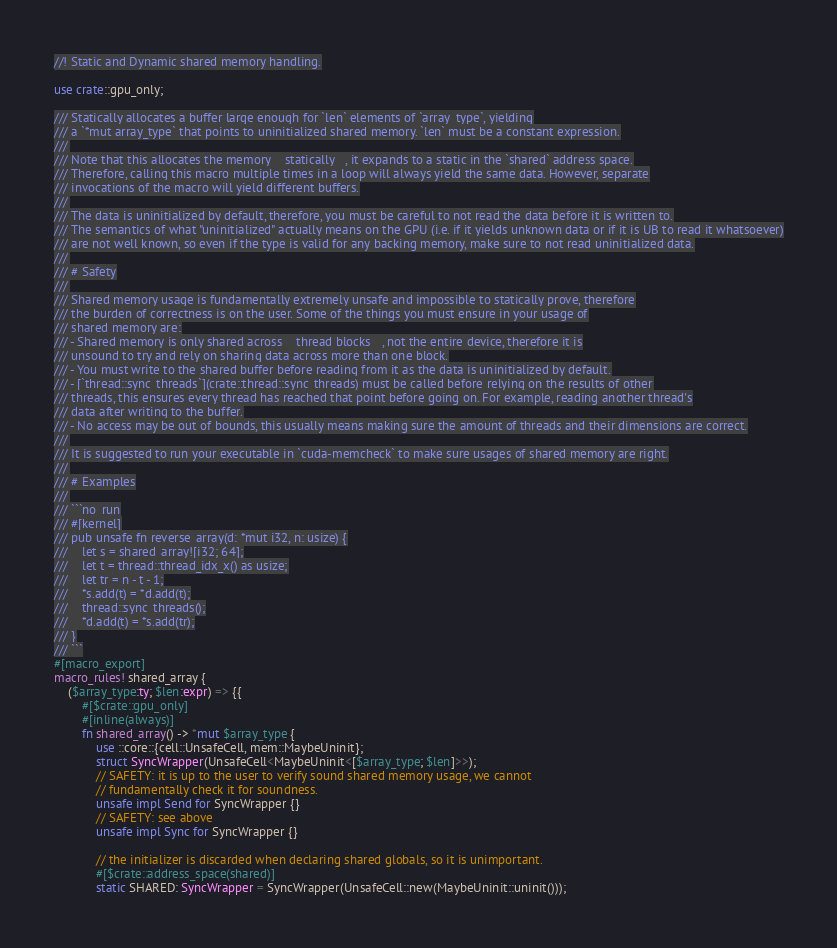<code> <loc_0><loc_0><loc_500><loc_500><_Rust_>//! Static and Dynamic shared memory handling.

use crate::gpu_only;

/// Statically allocates a buffer large enough for `len` elements of `array_type`, yielding
/// a `*mut array_type` that points to uninitialized shared memory. `len` must be a constant expression.
///
/// Note that this allocates the memory __statically__, it expands to a static in the `shared` address space.
/// Therefore, calling this macro multiple times in a loop will always yield the same data. However, separate
/// invocations of the macro will yield different buffers.
///
/// The data is uninitialized by default, therefore, you must be careful to not read the data before it is written to.
/// The semantics of what "uninitialized" actually means on the GPU (i.e. if it yields unknown data or if it is UB to read it whatsoever)
/// are not well known, so even if the type is valid for any backing memory, make sure to not read uninitialized data.
///
/// # Safety
///
/// Shared memory usage is fundamentally extremely unsafe and impossible to statically prove, therefore
/// the burden of correctness is on the user. Some of the things you must ensure in your usage of
/// shared memory are:
/// - Shared memory is only shared across __thread blocks__, not the entire device, therefore it is
/// unsound to try and rely on sharing data across more than one block.
/// - You must write to the shared buffer before reading from it as the data is uninitialized by default.
/// - [`thread::sync_threads`](crate::thread::sync_threads) must be called before relying on the results of other
/// threads, this ensures every thread has reached that point before going on. For example, reading another thread's
/// data after writing to the buffer.
/// - No access may be out of bounds, this usually means making sure the amount of threads and their dimensions are correct.
///
/// It is suggested to run your executable in `cuda-memcheck` to make sure usages of shared memory are right.
///
/// # Examples
///
/// ```no_run
/// #[kernel]
/// pub unsafe fn reverse_array(d: *mut i32, n: usize) {
///    let s = shared_array![i32; 64];
///    let t = thread::thread_idx_x() as usize;
///    let tr = n - t - 1;
///    *s.add(t) = *d.add(t);
///    thread::sync_threads();
///    *d.add(t) = *s.add(tr);
/// }
/// ```
#[macro_export]
macro_rules! shared_array {
    ($array_type:ty; $len:expr) => {{
        #[$crate::gpu_only]
        #[inline(always)]
        fn shared_array() -> *mut $array_type {
            use ::core::{cell::UnsafeCell, mem::MaybeUninit};
            struct SyncWrapper(UnsafeCell<MaybeUninit<[$array_type; $len]>>);
            // SAFETY: it is up to the user to verify sound shared memory usage, we cannot
            // fundamentally check it for soundness.
            unsafe impl Send for SyncWrapper {}
            // SAFETY: see above
            unsafe impl Sync for SyncWrapper {}

            // the initializer is discarded when declaring shared globals, so it is unimportant.
            #[$crate::address_space(shared)]
            static SHARED: SyncWrapper = SyncWrapper(UnsafeCell::new(MaybeUninit::uninit()));
</code> 